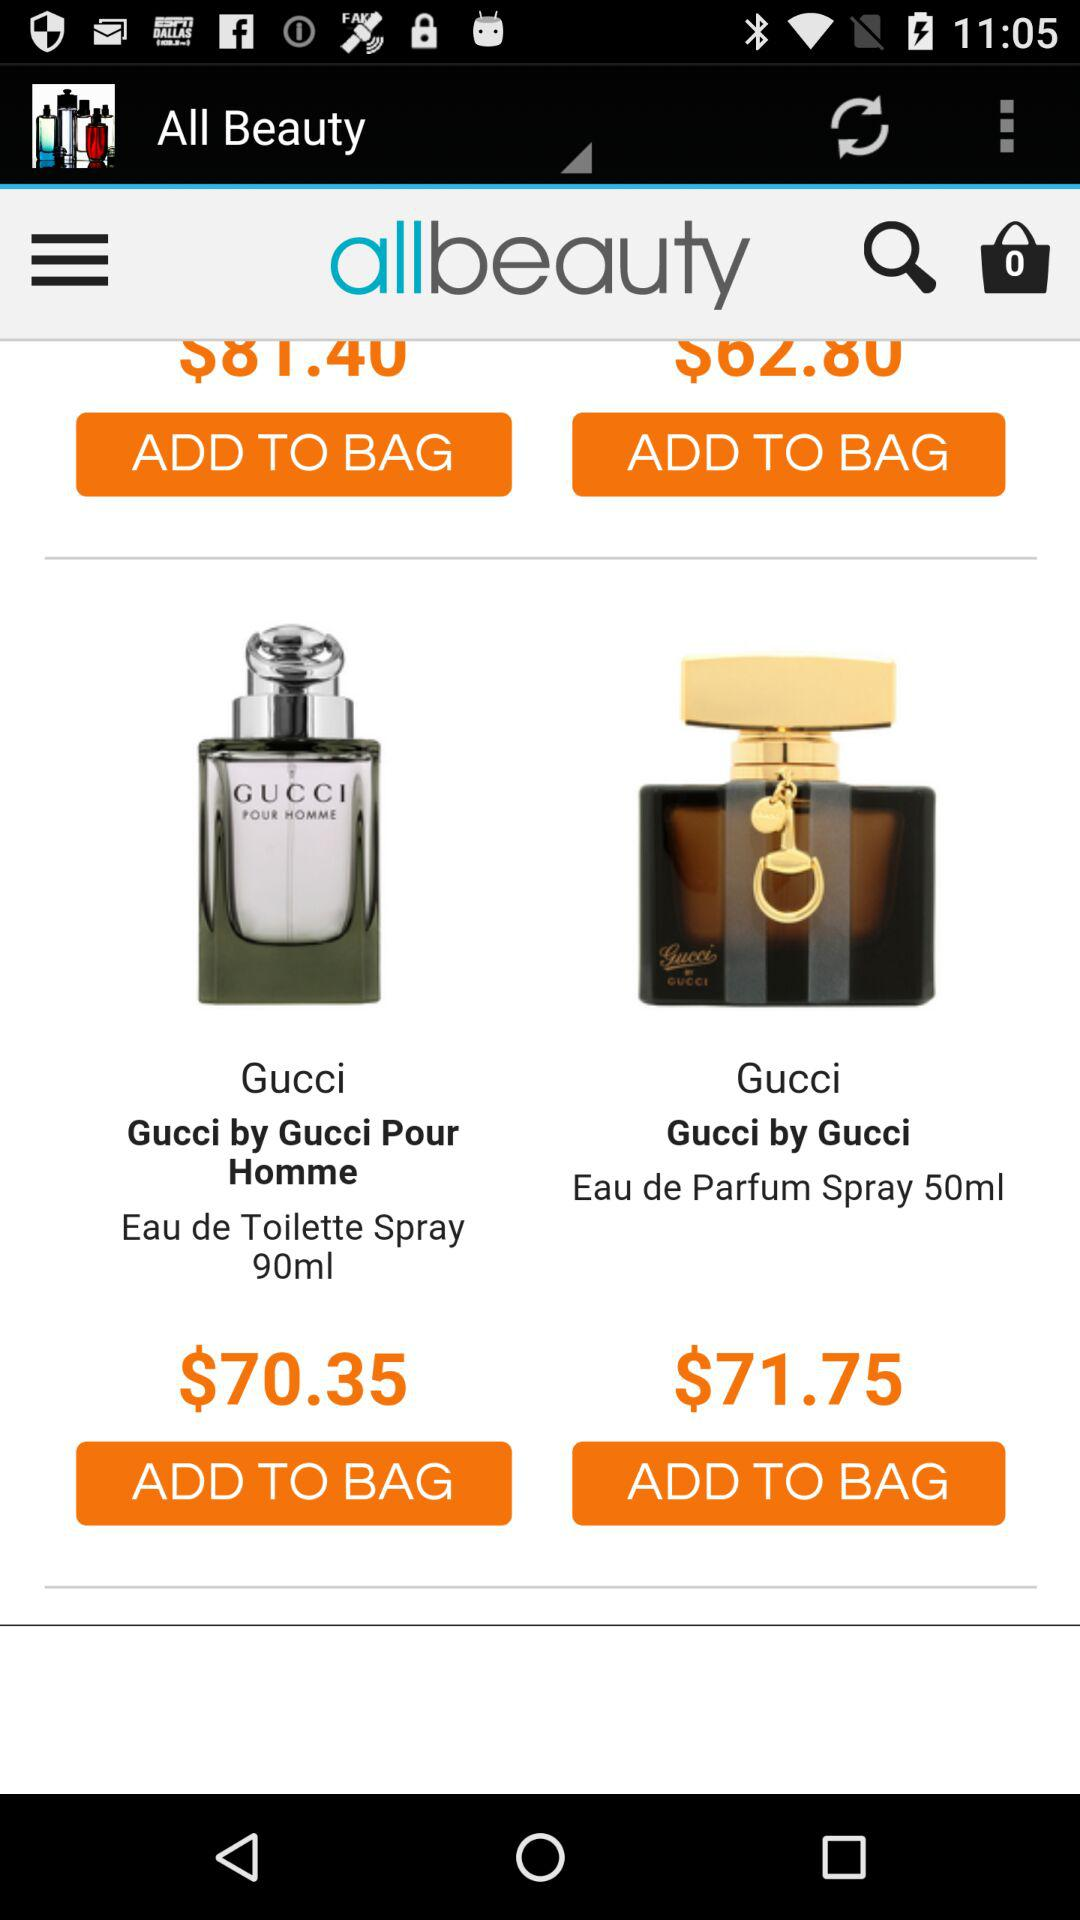What is the price of "Gucci Parfum Spray 50ml"? The price of "Gucci Parfum Spray 50ml" is $71.75. 